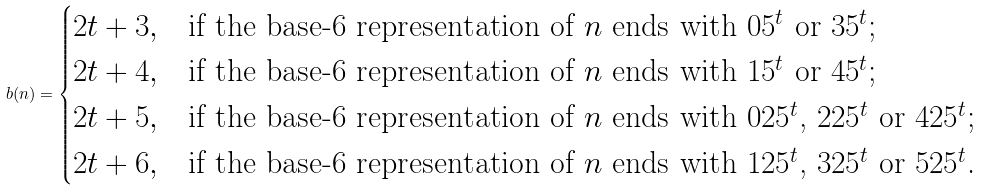<formula> <loc_0><loc_0><loc_500><loc_500>b ( n ) = \begin{cases} 2 t + 3 , & \text {if the base-$6$ representation of $n$ ends with $0 5^{t}$ or $3 5^{t}$;} \\ 2 t + 4 , & \text {if the base-$6$ representation of $n$ ends with $1 5^{t}$ or $4 5^{t}$;} \\ 2 t + 5 , & \text {if the base-$6$ representation of $n$ ends with $025^{t}$, $225^{t}$ or $425^{t}$;} \\ 2 t + 6 , & \text {if the base-$6$ representation of $n$ ends with $125^{t}$, $325^{t}$ or $525^{t}$.} \end{cases}</formula> 